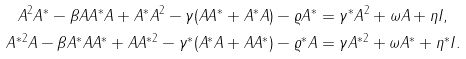<formula> <loc_0><loc_0><loc_500><loc_500>A ^ { 2 } A ^ { * } - \beta A A ^ { * } A + A ^ { * } A ^ { 2 } - \gamma ( A A ^ { * } + A ^ { * } A ) - \varrho A ^ { * } & = \gamma ^ { * } A ^ { 2 } + \omega A + \eta I , \\ A ^ { * 2 } A - \beta A ^ { * } A A ^ { * } + A A ^ { * 2 } - \gamma ^ { * } ( A ^ { * } A + A A ^ { * } ) - \varrho ^ { * } A & = \gamma A ^ { * 2 } + \omega A ^ { * } + \eta ^ { * } I .</formula> 